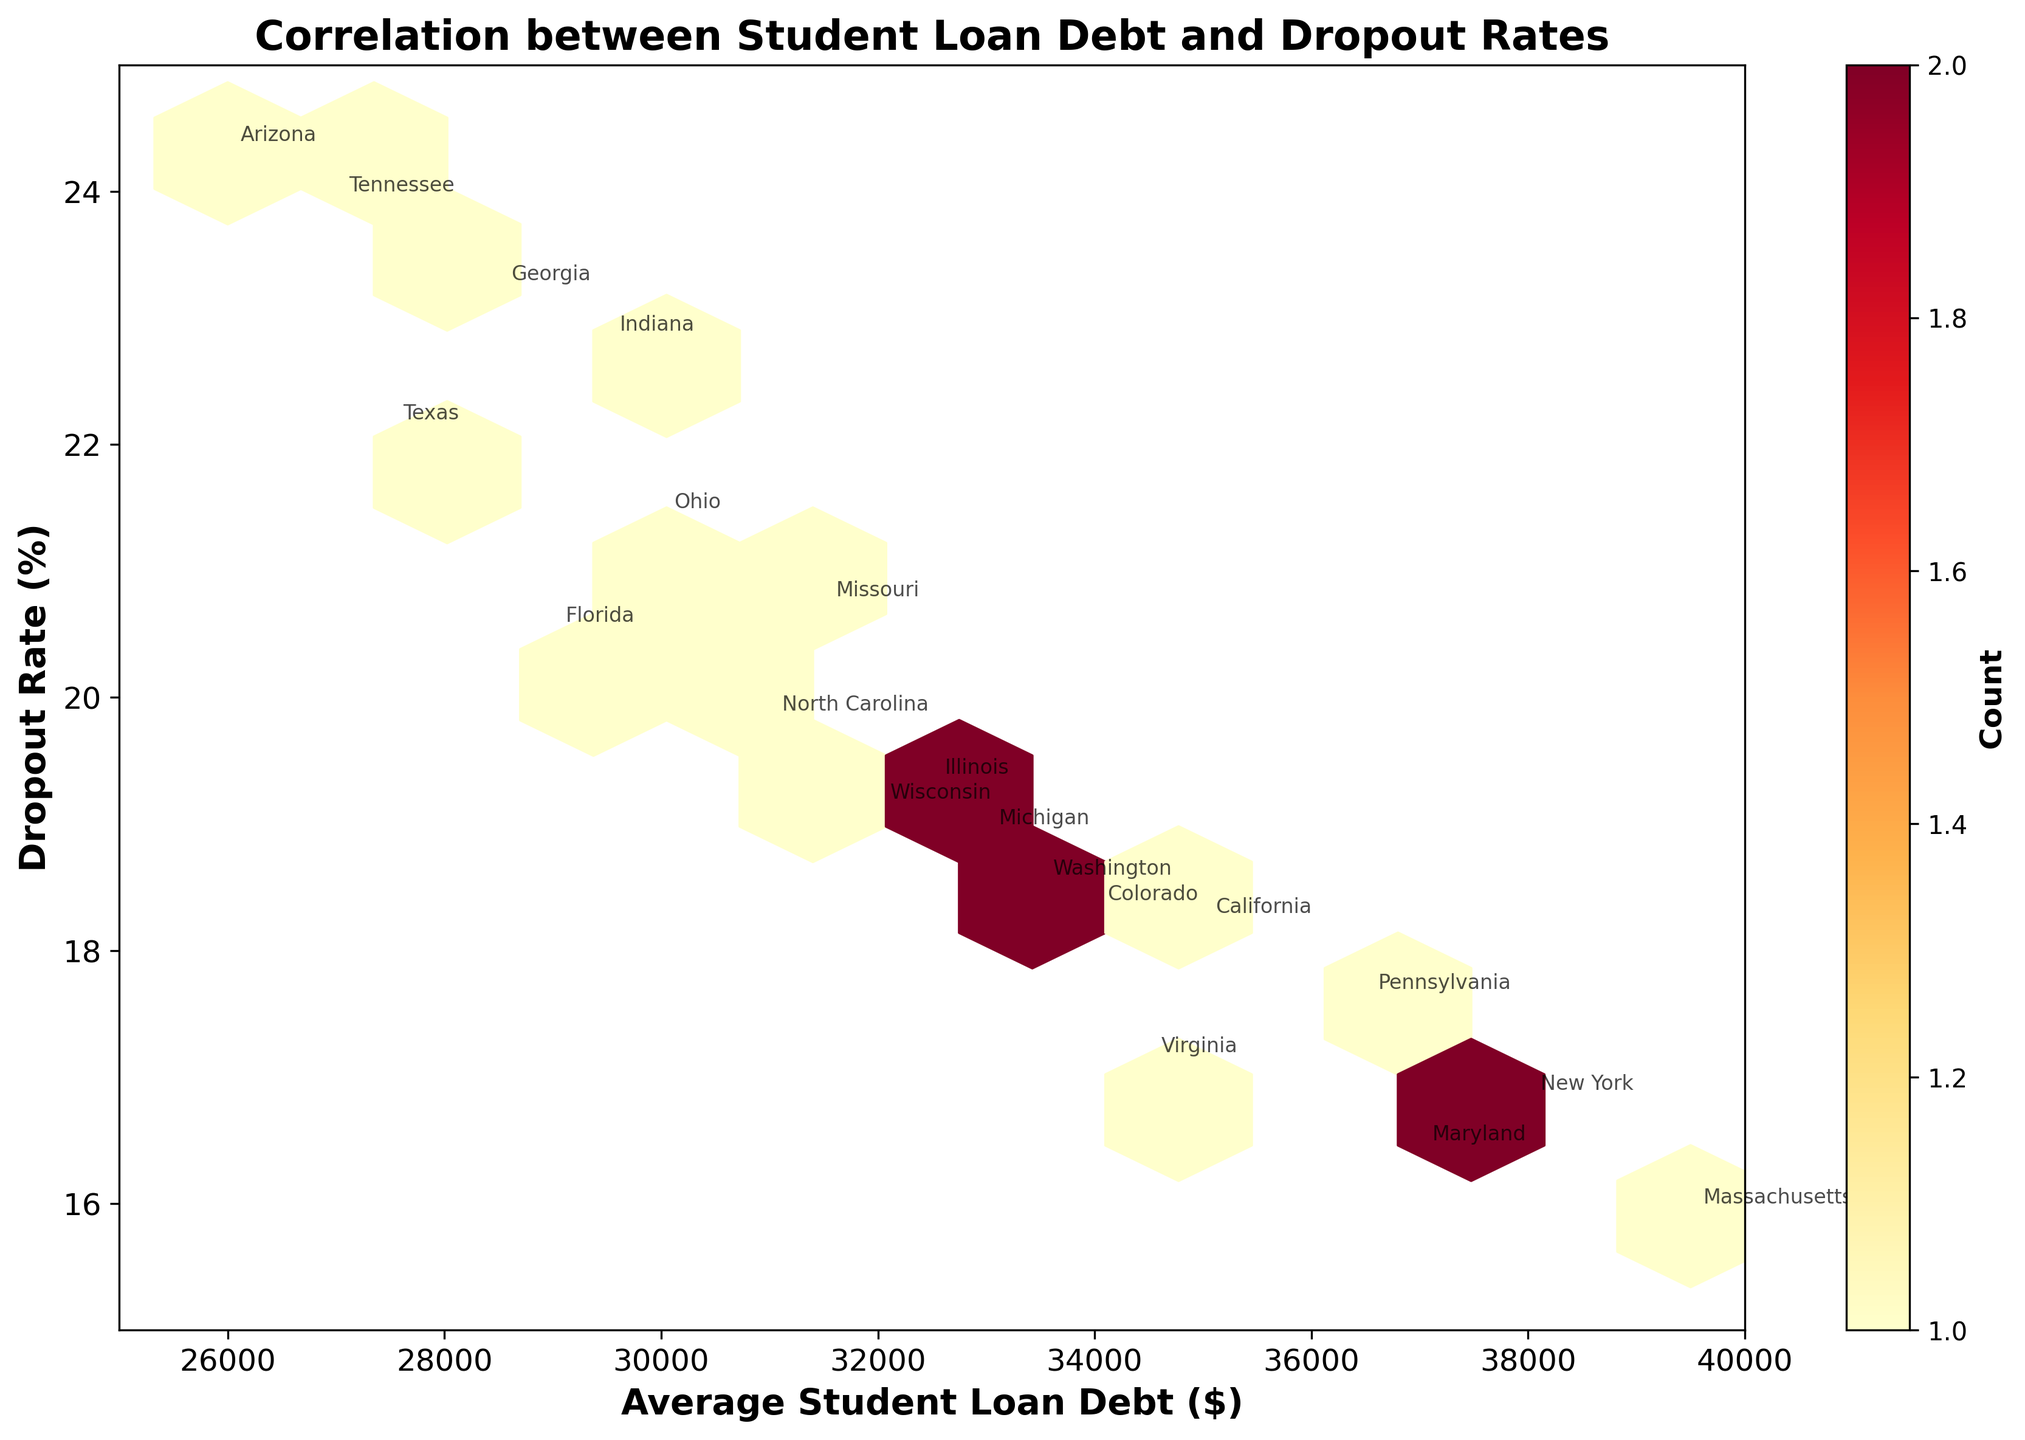What's the title of the figure? The title is usually displayed at the top of the figure. In this case, it should be easily identifiable in the plot area.
Answer: Correlation between Student Loan Debt and Dropout Rates What are the x-axis and y-axis labels? The labels for each axis are generally displayed along the respective axis. In this figure, you should see them clearly marked. The x-axis shows "Average Student Loan Debt ($)" and the y-axis shows "Dropout Rate (%)".
Answer: Average Student Loan Debt ($) and Dropout Rate (%) How many hexagons are there in the plot? Hexbin plots are made up of hexagonal bins. By visually inspecting the plotted area, you can count these hexagons to determine their number.
Answer: 10 (approximate) Which state has the highest average student loan debt? You need to look for the state annotated at the highest point along the x-axis. This state should be on the far right.
Answer: Massachusetts Which state has the highest dropout rate? Look for the state annotated at the highest point along the y-axis. This state should be at the top.
Answer: Arizona How many states fall into the bin with the most occurrences? The color bar on the plot helps to determine the count for each hexbin. Identify the hexbin with the darkest color and refer to the color bar to get the count number.
Answer: 3 (approximate) Are there more states with an average student loan debt above or below $30,000? Count the number of states above and below the $30,000 mark on the x-axis and compare the counts.
Answer: Above Is there a visible correlation between student loan debt and dropout rates? Examine the overall distribution of the points in the hexbin plot. A visible pattern, either increasing or decreasing, would indicate a correlation.
Answer: Yes, slightly positive Which state has both high average student loan debt and a low dropout rate? Look for the state that is annotated towards the right on the x-axis and lower on the y-axis. This state should be near the bottom right corner.
Answer: Massachusetts Is the student loan debt in Texas more than that in Arizona? Find the annotations for Texas and Arizona and compare their x-axis positions. Texas should be more to the right to have a higher debt.
Answer: Yes 